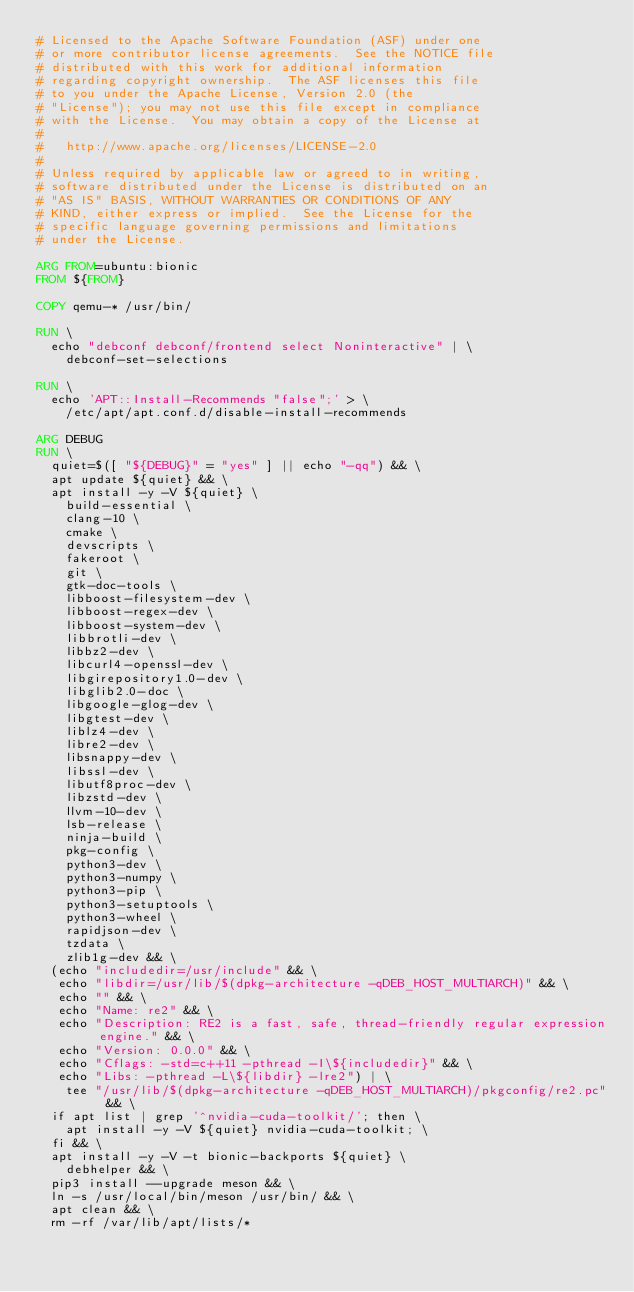<code> <loc_0><loc_0><loc_500><loc_500><_Dockerfile_># Licensed to the Apache Software Foundation (ASF) under one
# or more contributor license agreements.  See the NOTICE file
# distributed with this work for additional information
# regarding copyright ownership.  The ASF licenses this file
# to you under the Apache License, Version 2.0 (the
# "License"); you may not use this file except in compliance
# with the License.  You may obtain a copy of the License at
#
#   http://www.apache.org/licenses/LICENSE-2.0
#
# Unless required by applicable law or agreed to in writing,
# software distributed under the License is distributed on an
# "AS IS" BASIS, WITHOUT WARRANTIES OR CONDITIONS OF ANY
# KIND, either express or implied.  See the License for the
# specific language governing permissions and limitations
# under the License.

ARG FROM=ubuntu:bionic
FROM ${FROM}

COPY qemu-* /usr/bin/

RUN \
  echo "debconf debconf/frontend select Noninteractive" | \
    debconf-set-selections

RUN \
  echo 'APT::Install-Recommends "false";' > \
    /etc/apt/apt.conf.d/disable-install-recommends

ARG DEBUG
RUN \
  quiet=$([ "${DEBUG}" = "yes" ] || echo "-qq") && \
  apt update ${quiet} && \
  apt install -y -V ${quiet} \
    build-essential \
    clang-10 \
    cmake \
    devscripts \
    fakeroot \
    git \
    gtk-doc-tools \
    libboost-filesystem-dev \
    libboost-regex-dev \
    libboost-system-dev \
    libbrotli-dev \
    libbz2-dev \
    libcurl4-openssl-dev \
    libgirepository1.0-dev \
    libglib2.0-doc \
    libgoogle-glog-dev \
    libgtest-dev \
    liblz4-dev \
    libre2-dev \
    libsnappy-dev \
    libssl-dev \
    libutf8proc-dev \
    libzstd-dev \
    llvm-10-dev \
    lsb-release \
    ninja-build \
    pkg-config \
    python3-dev \
    python3-numpy \
    python3-pip \
    python3-setuptools \
    python3-wheel \
    rapidjson-dev \
    tzdata \
    zlib1g-dev && \
  (echo "includedir=/usr/include" && \
   echo "libdir=/usr/lib/$(dpkg-architecture -qDEB_HOST_MULTIARCH)" && \
   echo "" && \
   echo "Name: re2" && \
   echo "Description: RE2 is a fast, safe, thread-friendly regular expression engine." && \
   echo "Version: 0.0.0" && \
   echo "Cflags: -std=c++11 -pthread -I\${includedir}" && \
   echo "Libs: -pthread -L\${libdir} -lre2") | \
    tee "/usr/lib/$(dpkg-architecture -qDEB_HOST_MULTIARCH)/pkgconfig/re2.pc" && \
  if apt list | grep '^nvidia-cuda-toolkit/'; then \
    apt install -y -V ${quiet} nvidia-cuda-toolkit; \
  fi && \
  apt install -y -V -t bionic-backports ${quiet} \
    debhelper && \
  pip3 install --upgrade meson && \
  ln -s /usr/local/bin/meson /usr/bin/ && \
  apt clean && \
  rm -rf /var/lib/apt/lists/*
</code> 